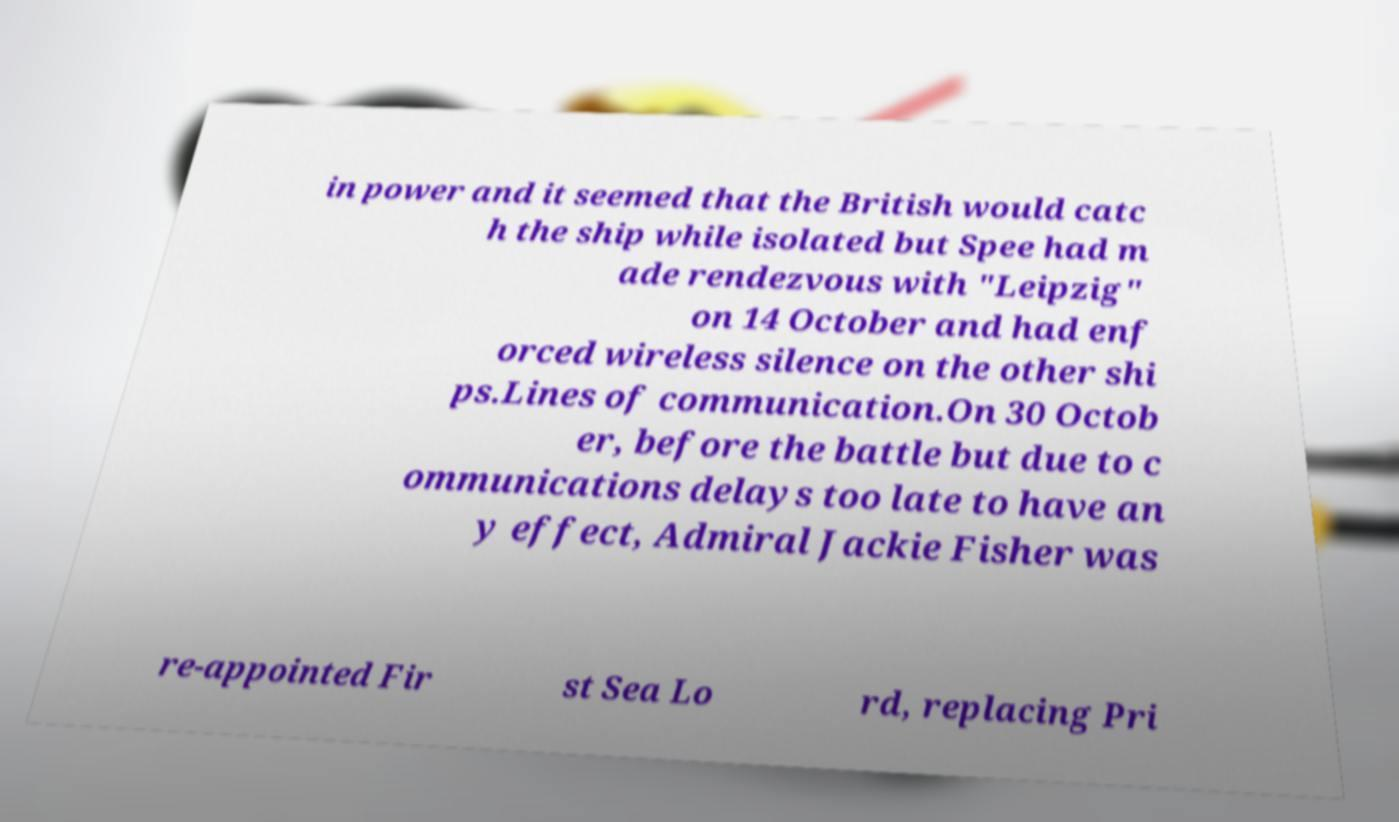Can you read and provide the text displayed in the image?This photo seems to have some interesting text. Can you extract and type it out for me? in power and it seemed that the British would catc h the ship while isolated but Spee had m ade rendezvous with "Leipzig" on 14 October and had enf orced wireless silence on the other shi ps.Lines of communication.On 30 Octob er, before the battle but due to c ommunications delays too late to have an y effect, Admiral Jackie Fisher was re-appointed Fir st Sea Lo rd, replacing Pri 